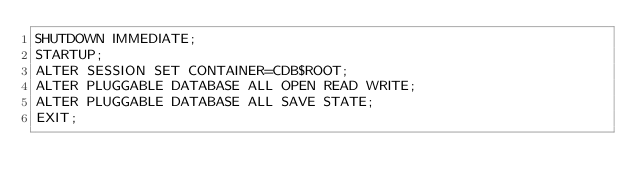Convert code to text. <code><loc_0><loc_0><loc_500><loc_500><_SQL_>SHUTDOWN IMMEDIATE;
STARTUP;
ALTER SESSION SET CONTAINER=CDB$ROOT;
ALTER PLUGGABLE DATABASE ALL OPEN READ WRITE;
ALTER PLUGGABLE DATABASE ALL SAVE STATE;
EXIT;
</code> 